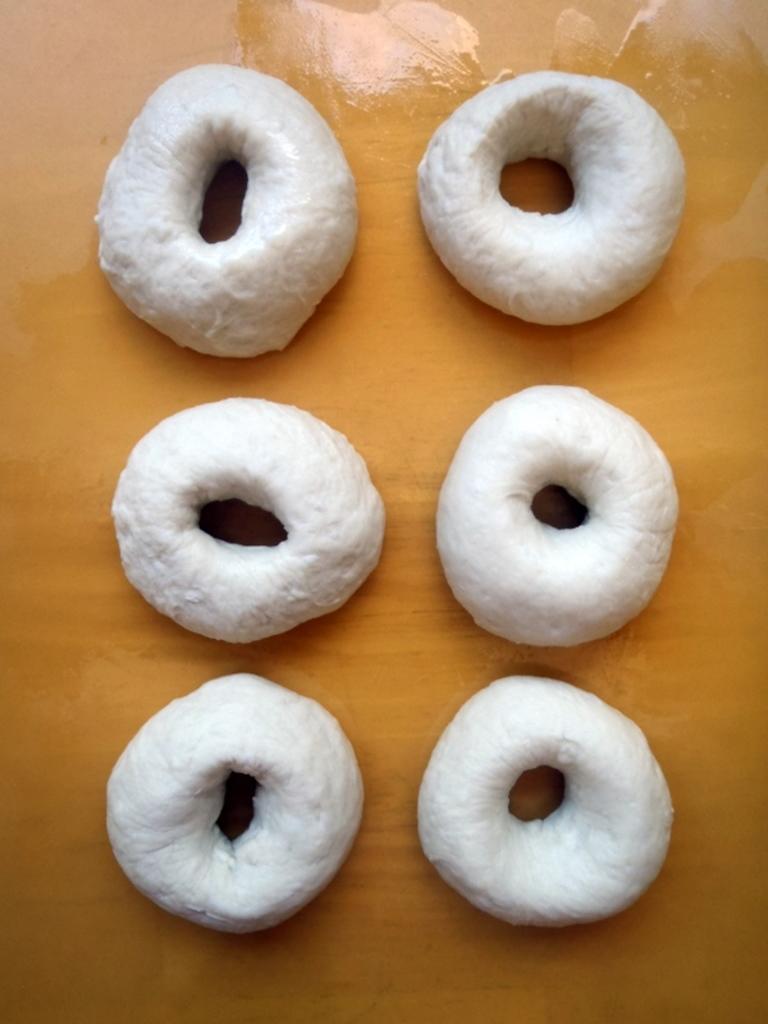In one or two sentences, can you explain what this image depicts? Here in this picture we can see some unbaked doughnuts present on a table. 